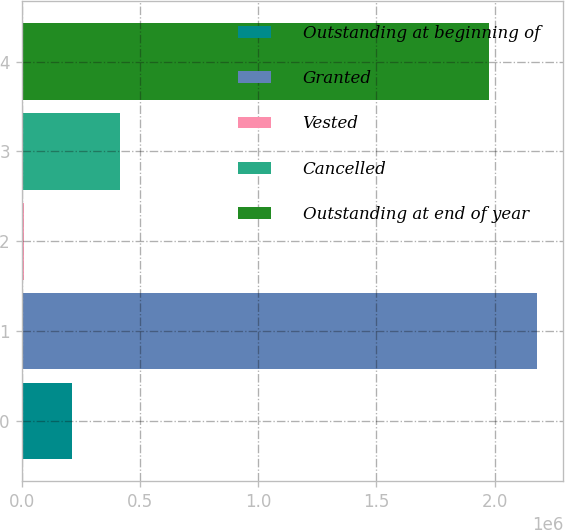Convert chart to OTSL. <chart><loc_0><loc_0><loc_500><loc_500><bar_chart><fcel>Outstanding at beginning of<fcel>Granted<fcel>Vested<fcel>Cancelled<fcel>Outstanding at end of year<nl><fcel>214689<fcel>2.18073e+06<fcel>12221<fcel>417157<fcel>1.97826e+06<nl></chart> 